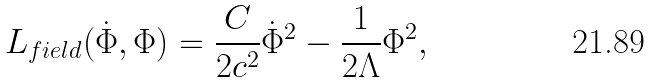<formula> <loc_0><loc_0><loc_500><loc_500>L _ { f i e l d } ( \dot { \Phi } , \Phi ) = \frac { C } { 2 c ^ { 2 } } \dot { \Phi } ^ { 2 } - \frac { 1 } { 2 \Lambda } \Phi ^ { 2 } ,</formula> 